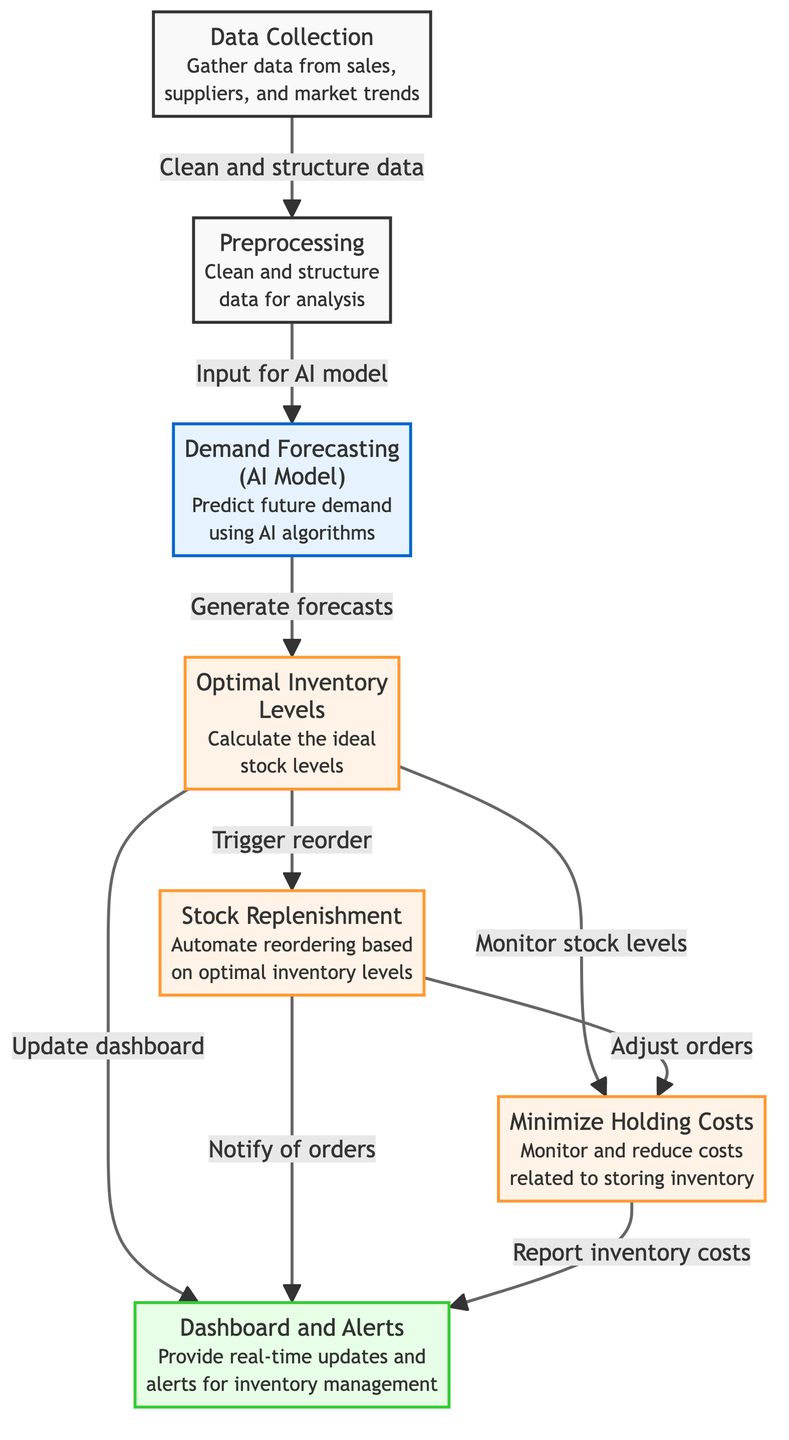What is the first step in the inventory management process? The first step in the diagram is "Data Collection," which indicates that the process begins with gathering data necessary for inventory management.
Answer: Data Collection How many processes are illustrated in the diagram? The diagram includes five process nodes (Data Collection is not counted as a process). The processes are Preprocessing, Optimal Inventory Levels, Stock Replenishment, Minimize Holding Costs, and Dashboard and Alerts.
Answer: Five What type of node is "Demand Forecasting"? “Demand Forecasting” is represented as an AI Model node, which is specifically highlighted as using AI algorithms for forecasting future demand.
Answer: AI Model Which nodes trigger notifications to the dashboard? The nodes that trigger updates to the dashboard are "Optimal Inventory Levels" and "Stock Replenishment," as they both have arrows leading to the "Dashboard and Alerts" node.
Answer: Optimal Inventory Levels, Stock Replenishment What step follows the "Preprocessing" node? The "Demand Forecasting" step follows "Preprocessing," as indicated by the arrow connecting these two nodes in the sequence of the flow diagram.
Answer: Demand Forecasting How does "Stock Replenishment" interact with "Minimize Holding Costs"? "Stock Replenishment" adjusts orders based on the interactions with "Minimize Holding Costs," indicating there is a feedback loop where order adjustments can influence holding cost management.
Answer: Adjust orders Which node provides alerts for inventory management? The "Dashboard and Alerts" node is the one that provides real-time updates and alerts related to inventory management, as stated directly in its description.
Answer: Dashboard and Alerts What is the outcome generated from the "Demand Forecasting"? The outcome from the "Demand Forecasting" node is the calculation of "Optimal Inventory Levels," which are designed to reflect the demand predictions from the AI model.
Answer: Optimal Inventory Levels Which step comes before "Minimize Holding Costs"? The step that comes before "Minimize Holding Costs" is "Optimal Inventory Levels," since it monitors stock levels that then leads to minimizing related costs.
Answer: Optimal Inventory Levels 